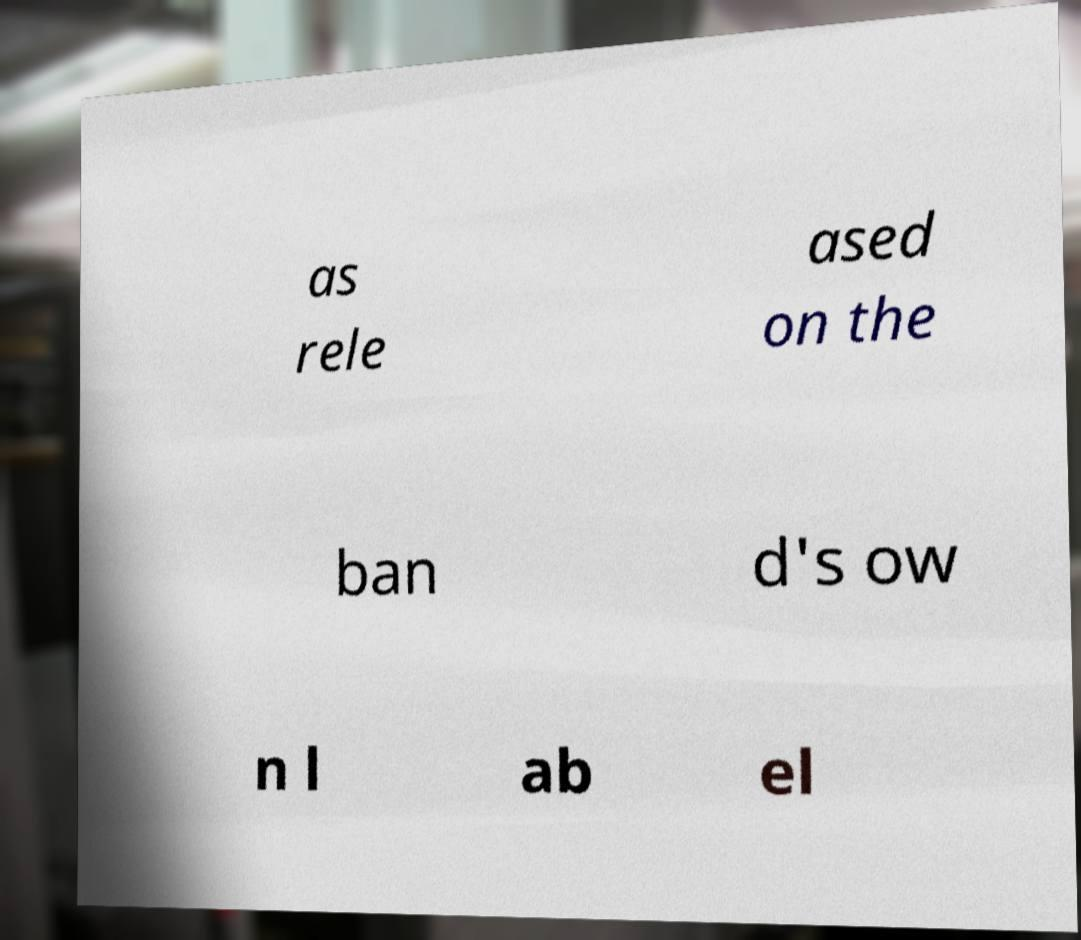Could you assist in decoding the text presented in this image and type it out clearly? as rele ased on the ban d's ow n l ab el 